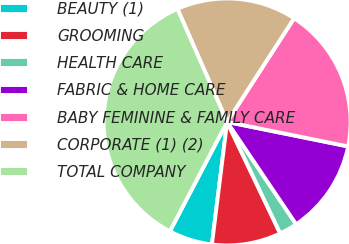<chart> <loc_0><loc_0><loc_500><loc_500><pie_chart><fcel>BEAUTY (1)<fcel>GROOMING<fcel>HEALTH CARE<fcel>FABRIC & HOME CARE<fcel>BABY FEMININE & FAMILY CARE<fcel>CORPORATE (1) (2)<fcel>TOTAL COMPANY<nl><fcel>5.71%<fcel>9.04%<fcel>2.37%<fcel>12.38%<fcel>19.05%<fcel>15.72%<fcel>35.74%<nl></chart> 